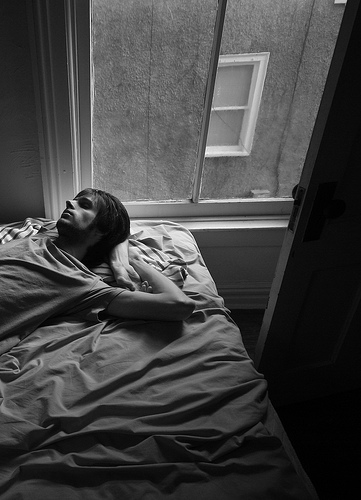How does the light affect the mood of the room? The light entering through the open window bathes the room in a soft, natural glow that creates a peaceful and tranquil atmosphere. 